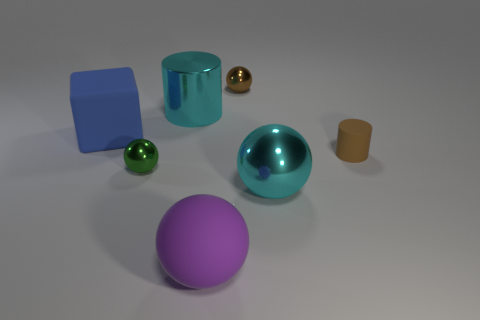What can you tell me about the different materials rendered in this image? The image showcases a variety of materials with different properties. The spheres have a high gloss, reflecting the environment and providing a sense of smoothness. The cyan sphere and cylinder exhibit a metallic sheen, suggesting a reflective and polished metal surface, while the golden sphere possesses a reflective, yet slightly textured finish. The cube and the small cylinder exhibit a matte finish, indicating a more absorbent material that diffuses light evenly, such as plastic or painted wood. 